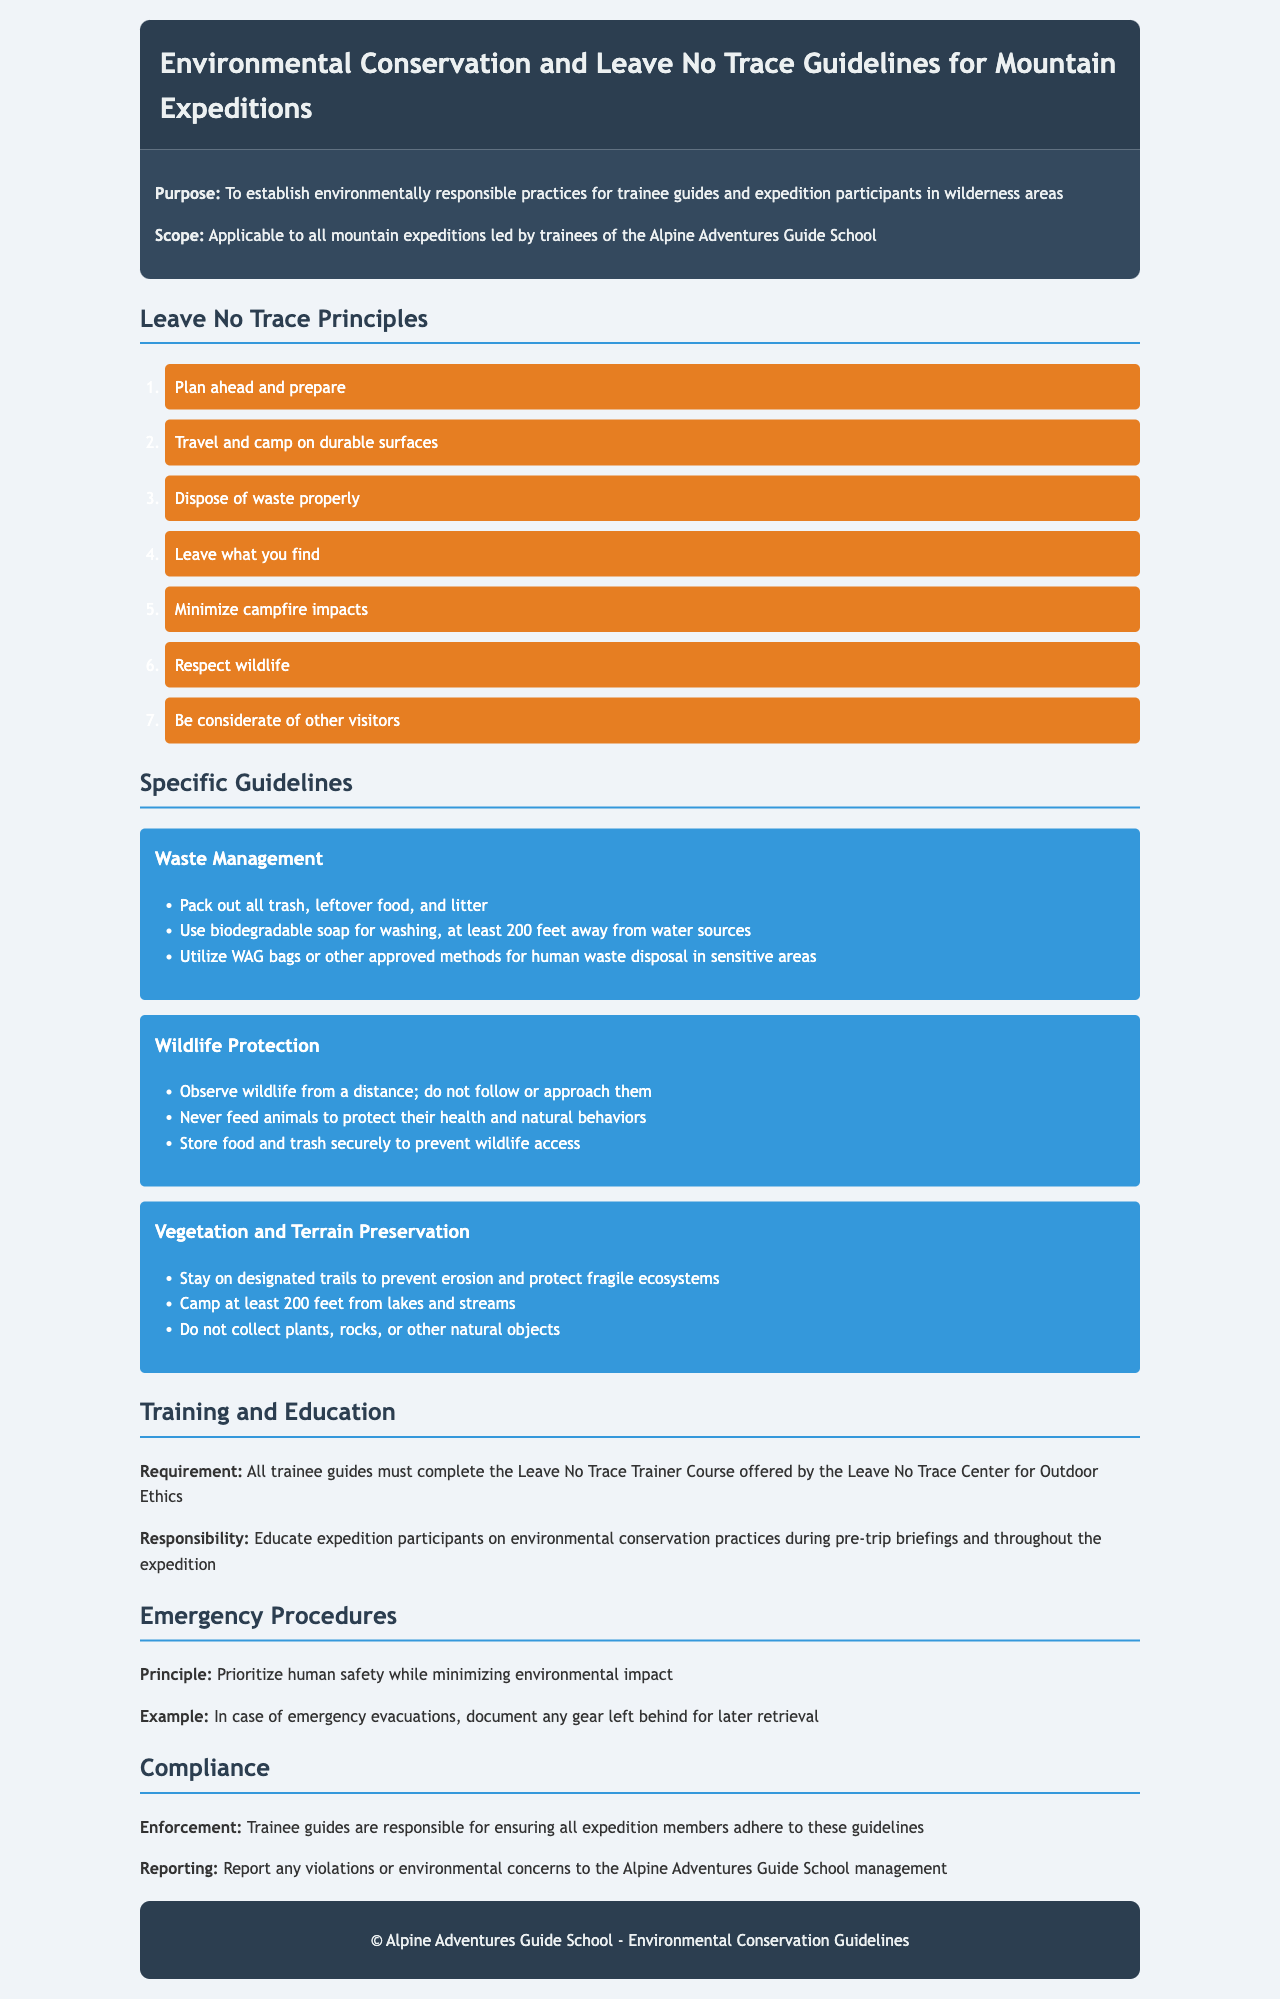What is the purpose of the guidelines? The purpose of the guidelines is to establish environmentally responsible practices for trainee guides and expedition participants in wilderness areas.
Answer: environmentally responsible practices How many Leave No Trace Principles are listed? The document lists a total of seven Leave No Trace Principles.
Answer: 7 What must trainee guides complete as a requirement? Trainee guides must complete the Leave No Trace Trainer Course.
Answer: Leave No Trace Trainer Course What should you do with trash and leftover food? All trash, leftover food, and litter must be packed out.
Answer: Pack out all trash How far should you camp from lakes and streams? You should camp at least 200 feet from lakes and streams.
Answer: 200 feet What is the main principle in emergency procedures? The main principle is to prioritize human safety while minimizing environmental impact.
Answer: prioritize human safety In case of emergency evacuations, what should be documented? Any gear left behind should be documented for later retrieval.
Answer: gear left behind 